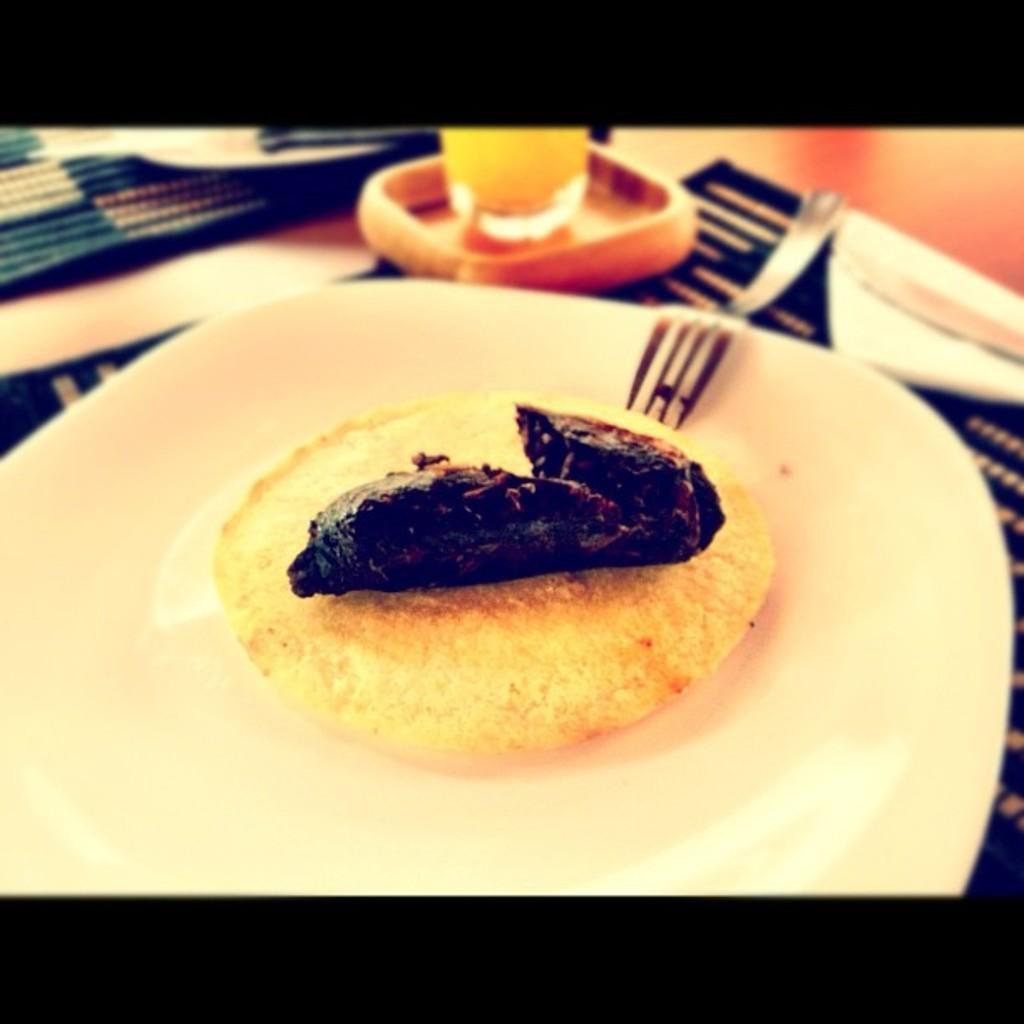Could you give a brief overview of what you see in this image? In this image there is a food item and a fork placed on a plate, beside the plate there is a glass of drink which is placed on top of the table. 